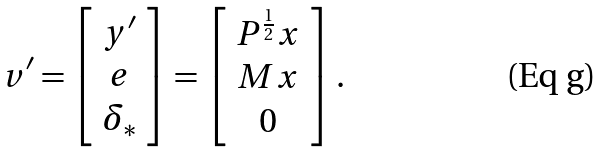Convert formula to latex. <formula><loc_0><loc_0><loc_500><loc_500>v ^ { \prime } = \left [ \begin{array} { c } y ^ { \prime } \\ e \\ \delta _ { * } \end{array} \right ] = \left [ \begin{array} { c } P ^ { \frac { 1 } { 2 } } x \\ M x \\ 0 \end{array} \right ] .</formula> 